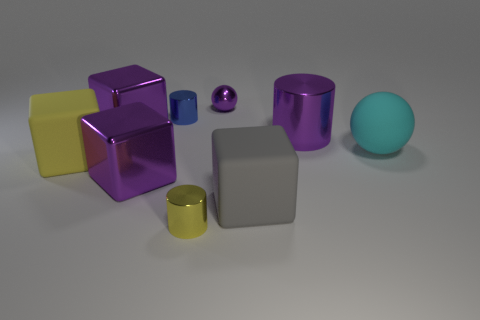What is the material of the yellow object that is the same shape as the gray matte thing? The yellow object, which shares the same cube shape as the gray matte item, appears to be made of a glossy plastic material. Its reflective surface and vibrant color are typical of plastic objects designed for aesthetic appeal. 